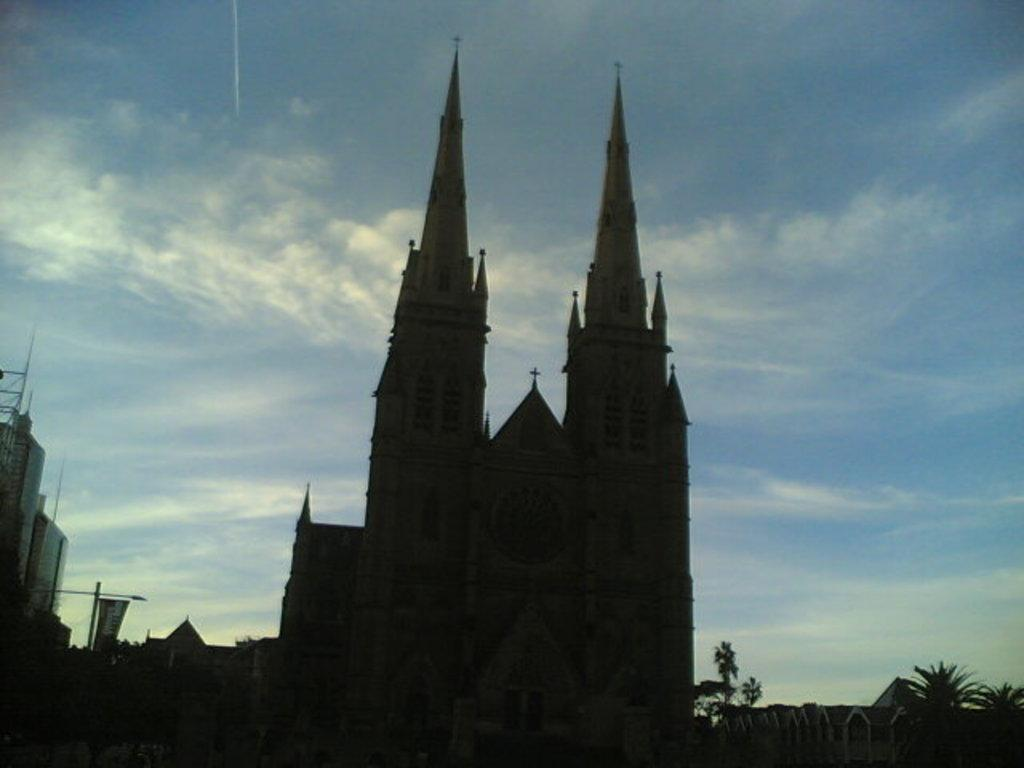What is the main structure in the center of the image? There is a cathedral in the center of the image. What can be seen in the background of the image? There are buildings and trees in the background of the image. What is visible at the top of the image? The sky is visible at the top of the image. What type of gold object can be seen in the image? There is no gold object or statue present in the image. What season is depicted in the image? The provided facts do not mention any seasonal elements, so it cannot be determined from the image. 